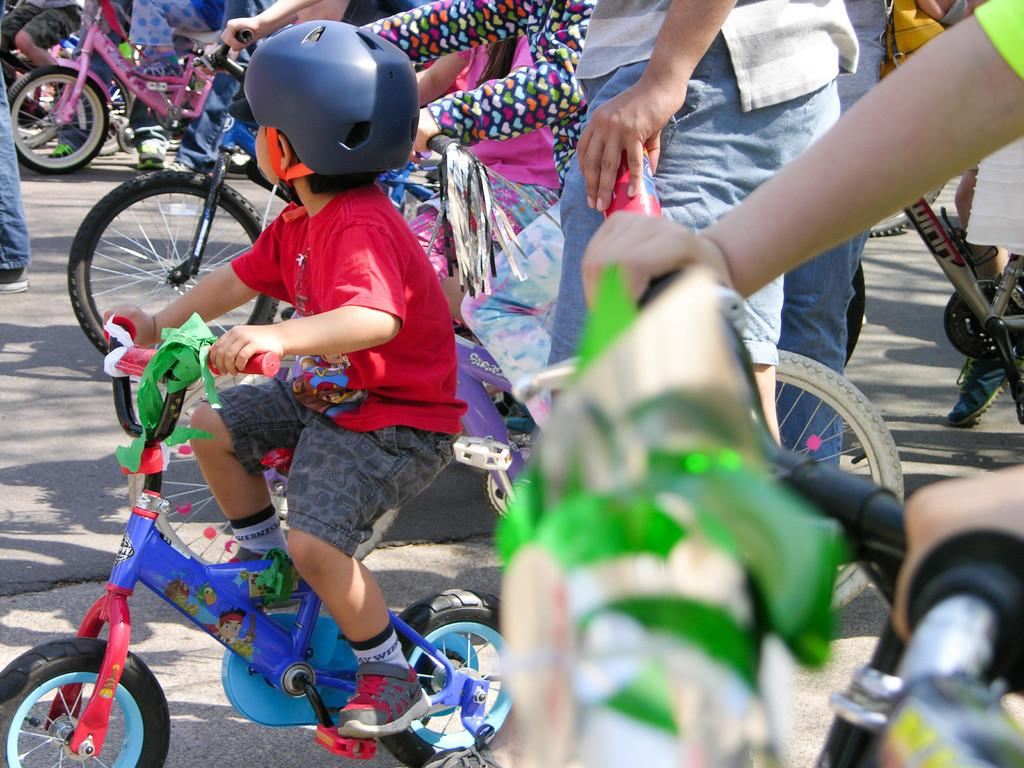What is the main subject of the image? The main subject of the image is a kid riding a bicycle. Where is the kid riding the bicycle? The kid is on a road. What can be seen in the background of the image? There are other persons in the background of the image. What are some of the persons in the background doing? Some of the persons in the background are standing, and some are also riding bicycles on the road. What type of iron can be seen in the image? There is no iron present in the image. How does the kid cover the distance on the road while riding the bicycle? The image does not show the kid covering any distance, as it is a still image. 